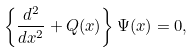<formula> <loc_0><loc_0><loc_500><loc_500>\left \{ \frac { d ^ { 2 } } { d x ^ { 2 } } + Q ( x ) \right \} \Psi ( x ) = 0 ,</formula> 